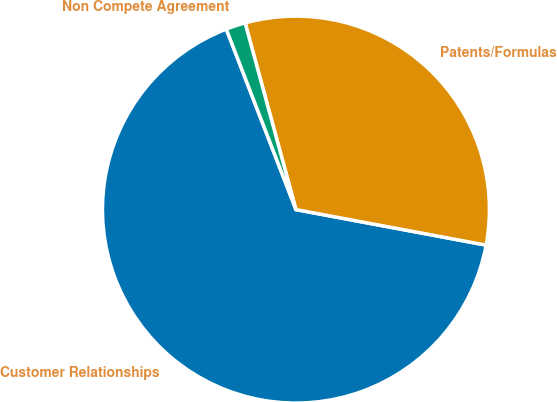Convert chart to OTSL. <chart><loc_0><loc_0><loc_500><loc_500><pie_chart><fcel>Customer Relationships<fcel>Patents/Formulas<fcel>Non Compete Agreement<nl><fcel>66.19%<fcel>32.17%<fcel>1.63%<nl></chart> 